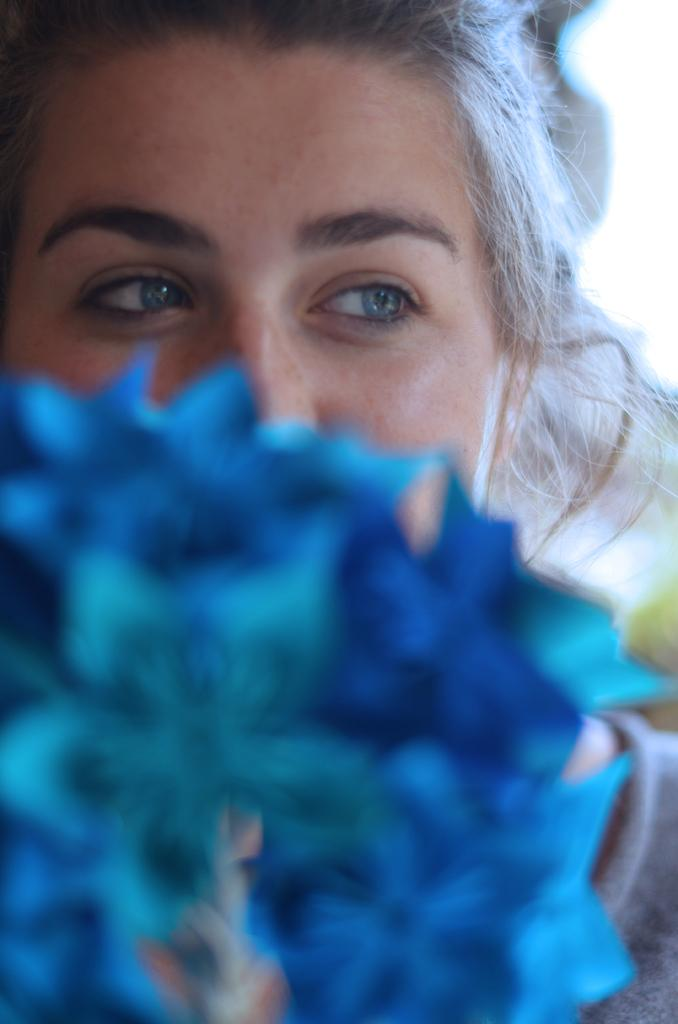What is the main subject of the picture? The main subject of the picture is a beautiful woman. What is the woman doing in the picture? The woman is covering her face with blue flowers. How many cats are visible in the picture? There are no cats present in the picture; it features a beautiful woman covering her face with blue flowers. What type of ink is being used to draw the blue flowers? The image is a photograph, not a drawing, so there is no ink present. 